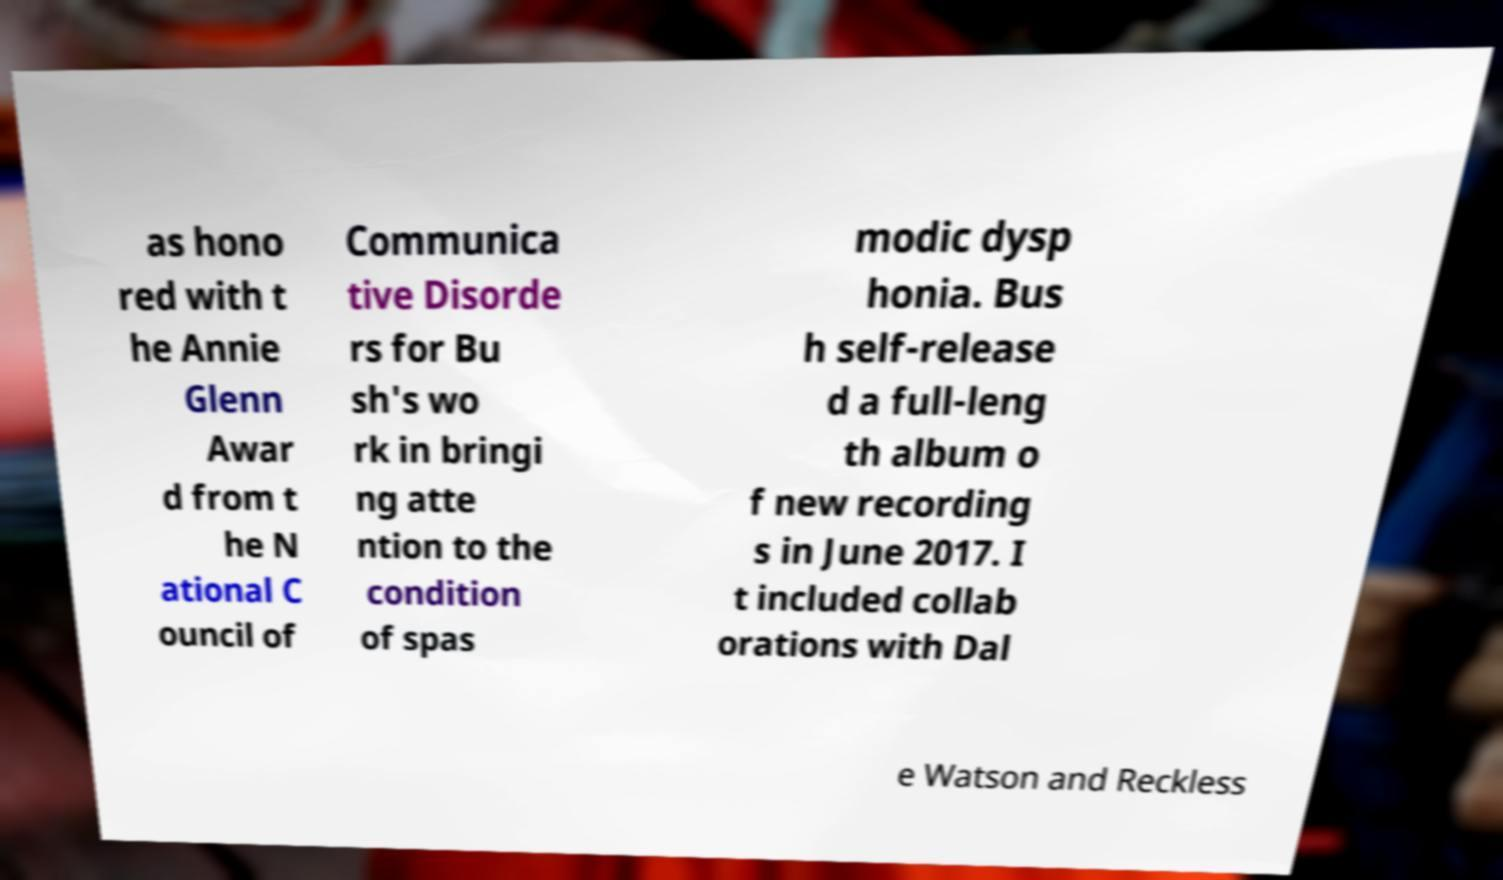Please read and relay the text visible in this image. What does it say? as hono red with t he Annie Glenn Awar d from t he N ational C ouncil of Communica tive Disorde rs for Bu sh's wo rk in bringi ng atte ntion to the condition of spas modic dysp honia. Bus h self-release d a full-leng th album o f new recording s in June 2017. I t included collab orations with Dal e Watson and Reckless 